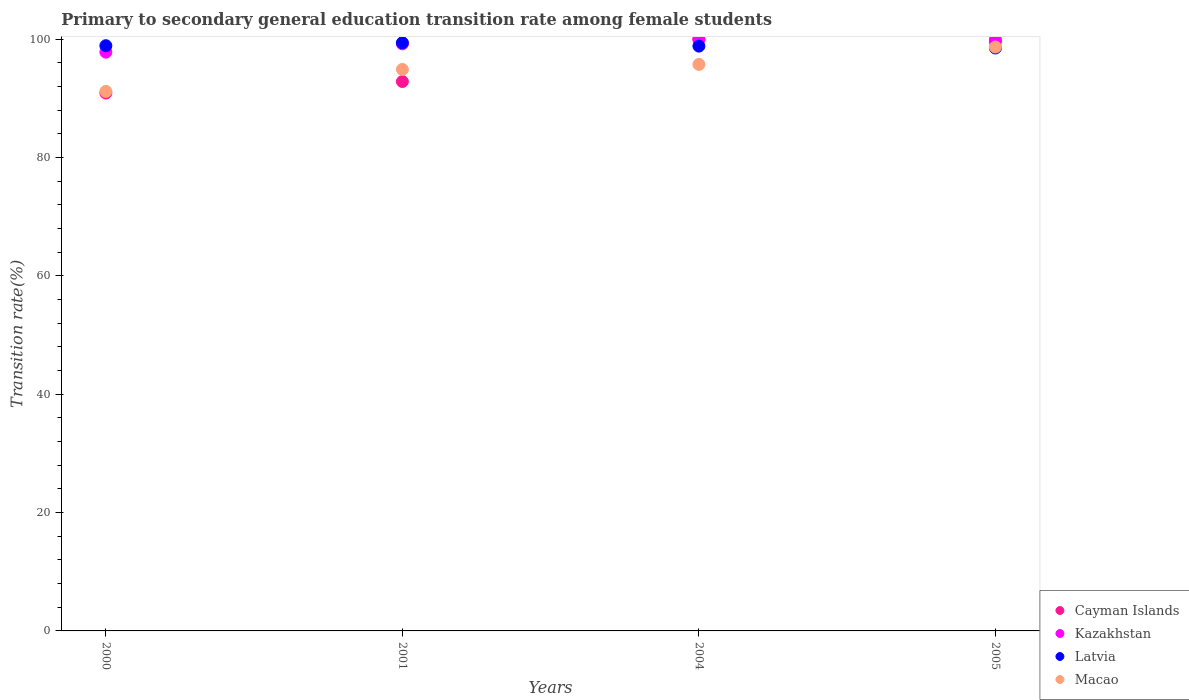How many different coloured dotlines are there?
Provide a short and direct response. 4. What is the transition rate in Cayman Islands in 2005?
Ensure brevity in your answer.  99.58. Across all years, what is the minimum transition rate in Latvia?
Offer a terse response. 98.52. In which year was the transition rate in Macao maximum?
Offer a terse response. 2005. What is the total transition rate in Macao in the graph?
Your response must be concise. 380.51. What is the difference between the transition rate in Kazakhstan in 2001 and that in 2004?
Give a very brief answer. -0.77. What is the difference between the transition rate in Macao in 2005 and the transition rate in Kazakhstan in 2000?
Ensure brevity in your answer.  0.86. What is the average transition rate in Latvia per year?
Offer a very short reply. 98.92. In the year 2000, what is the difference between the transition rate in Latvia and transition rate in Cayman Islands?
Provide a succinct answer. 8. In how many years, is the transition rate in Macao greater than 84 %?
Offer a terse response. 4. What is the ratio of the transition rate in Latvia in 2001 to that in 2004?
Provide a short and direct response. 1.01. Is the transition rate in Macao in 2000 less than that in 2001?
Provide a short and direct response. Yes. What is the difference between the highest and the second highest transition rate in Kazakhstan?
Give a very brief answer. 0.05. What is the difference between the highest and the lowest transition rate in Latvia?
Offer a terse response. 0.89. Is the sum of the transition rate in Cayman Islands in 2001 and 2004 greater than the maximum transition rate in Macao across all years?
Provide a succinct answer. Yes. Is it the case that in every year, the sum of the transition rate in Latvia and transition rate in Kazakhstan  is greater than the sum of transition rate in Macao and transition rate in Cayman Islands?
Offer a very short reply. Yes. Is it the case that in every year, the sum of the transition rate in Macao and transition rate in Latvia  is greater than the transition rate in Cayman Islands?
Give a very brief answer. Yes. Is the transition rate in Latvia strictly less than the transition rate in Cayman Islands over the years?
Keep it short and to the point. No. How many dotlines are there?
Keep it short and to the point. 4. How many years are there in the graph?
Offer a terse response. 4. Does the graph contain any zero values?
Offer a very short reply. No. Does the graph contain grids?
Provide a short and direct response. No. Where does the legend appear in the graph?
Make the answer very short. Bottom right. What is the title of the graph?
Make the answer very short. Primary to secondary general education transition rate among female students. What is the label or title of the X-axis?
Provide a succinct answer. Years. What is the label or title of the Y-axis?
Ensure brevity in your answer.  Transition rate(%). What is the Transition rate(%) in Cayman Islands in 2000?
Your answer should be compact. 90.91. What is the Transition rate(%) of Kazakhstan in 2000?
Provide a short and direct response. 97.82. What is the Transition rate(%) in Latvia in 2000?
Ensure brevity in your answer.  98.91. What is the Transition rate(%) of Macao in 2000?
Ensure brevity in your answer.  91.18. What is the Transition rate(%) in Cayman Islands in 2001?
Ensure brevity in your answer.  92.86. What is the Transition rate(%) in Kazakhstan in 2001?
Make the answer very short. 99.23. What is the Transition rate(%) of Latvia in 2001?
Offer a very short reply. 99.41. What is the Transition rate(%) of Macao in 2001?
Make the answer very short. 94.9. What is the Transition rate(%) in Cayman Islands in 2004?
Your response must be concise. 100. What is the Transition rate(%) of Latvia in 2004?
Make the answer very short. 98.84. What is the Transition rate(%) in Macao in 2004?
Your answer should be compact. 95.75. What is the Transition rate(%) in Cayman Islands in 2005?
Ensure brevity in your answer.  99.58. What is the Transition rate(%) of Kazakhstan in 2005?
Your answer should be compact. 99.95. What is the Transition rate(%) of Latvia in 2005?
Give a very brief answer. 98.52. What is the Transition rate(%) of Macao in 2005?
Make the answer very short. 98.68. Across all years, what is the maximum Transition rate(%) in Cayman Islands?
Provide a short and direct response. 100. Across all years, what is the maximum Transition rate(%) of Latvia?
Offer a terse response. 99.41. Across all years, what is the maximum Transition rate(%) in Macao?
Your answer should be very brief. 98.68. Across all years, what is the minimum Transition rate(%) in Cayman Islands?
Keep it short and to the point. 90.91. Across all years, what is the minimum Transition rate(%) in Kazakhstan?
Offer a very short reply. 97.82. Across all years, what is the minimum Transition rate(%) in Latvia?
Provide a succinct answer. 98.52. Across all years, what is the minimum Transition rate(%) of Macao?
Provide a succinct answer. 91.18. What is the total Transition rate(%) in Cayman Islands in the graph?
Your answer should be very brief. 383.34. What is the total Transition rate(%) of Kazakhstan in the graph?
Give a very brief answer. 397. What is the total Transition rate(%) in Latvia in the graph?
Your answer should be compact. 395.69. What is the total Transition rate(%) in Macao in the graph?
Ensure brevity in your answer.  380.51. What is the difference between the Transition rate(%) of Cayman Islands in 2000 and that in 2001?
Your response must be concise. -1.95. What is the difference between the Transition rate(%) in Kazakhstan in 2000 and that in 2001?
Provide a succinct answer. -1.41. What is the difference between the Transition rate(%) of Latvia in 2000 and that in 2001?
Provide a succinct answer. -0.5. What is the difference between the Transition rate(%) of Macao in 2000 and that in 2001?
Provide a short and direct response. -3.71. What is the difference between the Transition rate(%) in Cayman Islands in 2000 and that in 2004?
Keep it short and to the point. -9.09. What is the difference between the Transition rate(%) of Kazakhstan in 2000 and that in 2004?
Offer a very short reply. -2.18. What is the difference between the Transition rate(%) in Latvia in 2000 and that in 2004?
Your response must be concise. 0.07. What is the difference between the Transition rate(%) of Macao in 2000 and that in 2004?
Your answer should be very brief. -4.57. What is the difference between the Transition rate(%) in Cayman Islands in 2000 and that in 2005?
Make the answer very short. -8.67. What is the difference between the Transition rate(%) of Kazakhstan in 2000 and that in 2005?
Keep it short and to the point. -2.13. What is the difference between the Transition rate(%) of Latvia in 2000 and that in 2005?
Your answer should be very brief. 0.39. What is the difference between the Transition rate(%) in Macao in 2000 and that in 2005?
Give a very brief answer. -7.5. What is the difference between the Transition rate(%) of Cayman Islands in 2001 and that in 2004?
Offer a terse response. -7.14. What is the difference between the Transition rate(%) of Kazakhstan in 2001 and that in 2004?
Make the answer very short. -0.77. What is the difference between the Transition rate(%) in Latvia in 2001 and that in 2004?
Your answer should be very brief. 0.57. What is the difference between the Transition rate(%) in Macao in 2001 and that in 2004?
Offer a terse response. -0.85. What is the difference between the Transition rate(%) in Cayman Islands in 2001 and that in 2005?
Provide a short and direct response. -6.72. What is the difference between the Transition rate(%) of Kazakhstan in 2001 and that in 2005?
Keep it short and to the point. -0.72. What is the difference between the Transition rate(%) of Latvia in 2001 and that in 2005?
Offer a terse response. 0.89. What is the difference between the Transition rate(%) of Macao in 2001 and that in 2005?
Make the answer very short. -3.79. What is the difference between the Transition rate(%) of Cayman Islands in 2004 and that in 2005?
Offer a very short reply. 0.42. What is the difference between the Transition rate(%) of Kazakhstan in 2004 and that in 2005?
Provide a succinct answer. 0.05. What is the difference between the Transition rate(%) of Latvia in 2004 and that in 2005?
Make the answer very short. 0.32. What is the difference between the Transition rate(%) in Macao in 2004 and that in 2005?
Your answer should be compact. -2.93. What is the difference between the Transition rate(%) of Cayman Islands in 2000 and the Transition rate(%) of Kazakhstan in 2001?
Make the answer very short. -8.32. What is the difference between the Transition rate(%) of Cayman Islands in 2000 and the Transition rate(%) of Latvia in 2001?
Offer a very short reply. -8.5. What is the difference between the Transition rate(%) of Cayman Islands in 2000 and the Transition rate(%) of Macao in 2001?
Offer a very short reply. -3.99. What is the difference between the Transition rate(%) in Kazakhstan in 2000 and the Transition rate(%) in Latvia in 2001?
Give a very brief answer. -1.59. What is the difference between the Transition rate(%) of Kazakhstan in 2000 and the Transition rate(%) of Macao in 2001?
Your answer should be compact. 2.92. What is the difference between the Transition rate(%) in Latvia in 2000 and the Transition rate(%) in Macao in 2001?
Your answer should be very brief. 4.01. What is the difference between the Transition rate(%) in Cayman Islands in 2000 and the Transition rate(%) in Kazakhstan in 2004?
Your answer should be compact. -9.09. What is the difference between the Transition rate(%) in Cayman Islands in 2000 and the Transition rate(%) in Latvia in 2004?
Make the answer very short. -7.93. What is the difference between the Transition rate(%) of Cayman Islands in 2000 and the Transition rate(%) of Macao in 2004?
Keep it short and to the point. -4.84. What is the difference between the Transition rate(%) in Kazakhstan in 2000 and the Transition rate(%) in Latvia in 2004?
Your answer should be compact. -1.02. What is the difference between the Transition rate(%) of Kazakhstan in 2000 and the Transition rate(%) of Macao in 2004?
Your answer should be very brief. 2.07. What is the difference between the Transition rate(%) in Latvia in 2000 and the Transition rate(%) in Macao in 2004?
Give a very brief answer. 3.16. What is the difference between the Transition rate(%) in Cayman Islands in 2000 and the Transition rate(%) in Kazakhstan in 2005?
Offer a very short reply. -9.04. What is the difference between the Transition rate(%) in Cayman Islands in 2000 and the Transition rate(%) in Latvia in 2005?
Provide a short and direct response. -7.61. What is the difference between the Transition rate(%) of Cayman Islands in 2000 and the Transition rate(%) of Macao in 2005?
Provide a succinct answer. -7.78. What is the difference between the Transition rate(%) of Kazakhstan in 2000 and the Transition rate(%) of Latvia in 2005?
Provide a short and direct response. -0.7. What is the difference between the Transition rate(%) in Kazakhstan in 2000 and the Transition rate(%) in Macao in 2005?
Ensure brevity in your answer.  -0.86. What is the difference between the Transition rate(%) in Latvia in 2000 and the Transition rate(%) in Macao in 2005?
Give a very brief answer. 0.23. What is the difference between the Transition rate(%) of Cayman Islands in 2001 and the Transition rate(%) of Kazakhstan in 2004?
Give a very brief answer. -7.14. What is the difference between the Transition rate(%) of Cayman Islands in 2001 and the Transition rate(%) of Latvia in 2004?
Your answer should be compact. -5.98. What is the difference between the Transition rate(%) in Cayman Islands in 2001 and the Transition rate(%) in Macao in 2004?
Ensure brevity in your answer.  -2.89. What is the difference between the Transition rate(%) in Kazakhstan in 2001 and the Transition rate(%) in Latvia in 2004?
Ensure brevity in your answer.  0.39. What is the difference between the Transition rate(%) of Kazakhstan in 2001 and the Transition rate(%) of Macao in 2004?
Make the answer very short. 3.48. What is the difference between the Transition rate(%) of Latvia in 2001 and the Transition rate(%) of Macao in 2004?
Offer a very short reply. 3.66. What is the difference between the Transition rate(%) of Cayman Islands in 2001 and the Transition rate(%) of Kazakhstan in 2005?
Ensure brevity in your answer.  -7.1. What is the difference between the Transition rate(%) in Cayman Islands in 2001 and the Transition rate(%) in Latvia in 2005?
Your response must be concise. -5.67. What is the difference between the Transition rate(%) of Cayman Islands in 2001 and the Transition rate(%) of Macao in 2005?
Provide a short and direct response. -5.83. What is the difference between the Transition rate(%) in Kazakhstan in 2001 and the Transition rate(%) in Latvia in 2005?
Provide a succinct answer. 0.71. What is the difference between the Transition rate(%) in Kazakhstan in 2001 and the Transition rate(%) in Macao in 2005?
Your answer should be very brief. 0.54. What is the difference between the Transition rate(%) of Latvia in 2001 and the Transition rate(%) of Macao in 2005?
Provide a succinct answer. 0.72. What is the difference between the Transition rate(%) in Cayman Islands in 2004 and the Transition rate(%) in Kazakhstan in 2005?
Ensure brevity in your answer.  0.05. What is the difference between the Transition rate(%) of Cayman Islands in 2004 and the Transition rate(%) of Latvia in 2005?
Give a very brief answer. 1.48. What is the difference between the Transition rate(%) in Cayman Islands in 2004 and the Transition rate(%) in Macao in 2005?
Your response must be concise. 1.32. What is the difference between the Transition rate(%) in Kazakhstan in 2004 and the Transition rate(%) in Latvia in 2005?
Offer a terse response. 1.48. What is the difference between the Transition rate(%) in Kazakhstan in 2004 and the Transition rate(%) in Macao in 2005?
Keep it short and to the point. 1.32. What is the difference between the Transition rate(%) in Latvia in 2004 and the Transition rate(%) in Macao in 2005?
Make the answer very short. 0.16. What is the average Transition rate(%) in Cayman Islands per year?
Give a very brief answer. 95.84. What is the average Transition rate(%) in Kazakhstan per year?
Offer a terse response. 99.25. What is the average Transition rate(%) of Latvia per year?
Keep it short and to the point. 98.92. What is the average Transition rate(%) in Macao per year?
Ensure brevity in your answer.  95.13. In the year 2000, what is the difference between the Transition rate(%) in Cayman Islands and Transition rate(%) in Kazakhstan?
Make the answer very short. -6.91. In the year 2000, what is the difference between the Transition rate(%) of Cayman Islands and Transition rate(%) of Latvia?
Ensure brevity in your answer.  -8. In the year 2000, what is the difference between the Transition rate(%) of Cayman Islands and Transition rate(%) of Macao?
Give a very brief answer. -0.27. In the year 2000, what is the difference between the Transition rate(%) in Kazakhstan and Transition rate(%) in Latvia?
Give a very brief answer. -1.09. In the year 2000, what is the difference between the Transition rate(%) of Kazakhstan and Transition rate(%) of Macao?
Provide a short and direct response. 6.64. In the year 2000, what is the difference between the Transition rate(%) of Latvia and Transition rate(%) of Macao?
Your answer should be compact. 7.73. In the year 2001, what is the difference between the Transition rate(%) of Cayman Islands and Transition rate(%) of Kazakhstan?
Offer a very short reply. -6.37. In the year 2001, what is the difference between the Transition rate(%) of Cayman Islands and Transition rate(%) of Latvia?
Provide a succinct answer. -6.55. In the year 2001, what is the difference between the Transition rate(%) of Cayman Islands and Transition rate(%) of Macao?
Ensure brevity in your answer.  -2.04. In the year 2001, what is the difference between the Transition rate(%) in Kazakhstan and Transition rate(%) in Latvia?
Give a very brief answer. -0.18. In the year 2001, what is the difference between the Transition rate(%) in Kazakhstan and Transition rate(%) in Macao?
Make the answer very short. 4.33. In the year 2001, what is the difference between the Transition rate(%) of Latvia and Transition rate(%) of Macao?
Make the answer very short. 4.51. In the year 2004, what is the difference between the Transition rate(%) of Cayman Islands and Transition rate(%) of Latvia?
Your answer should be compact. 1.16. In the year 2004, what is the difference between the Transition rate(%) in Cayman Islands and Transition rate(%) in Macao?
Give a very brief answer. 4.25. In the year 2004, what is the difference between the Transition rate(%) in Kazakhstan and Transition rate(%) in Latvia?
Keep it short and to the point. 1.16. In the year 2004, what is the difference between the Transition rate(%) in Kazakhstan and Transition rate(%) in Macao?
Your answer should be very brief. 4.25. In the year 2004, what is the difference between the Transition rate(%) in Latvia and Transition rate(%) in Macao?
Keep it short and to the point. 3.09. In the year 2005, what is the difference between the Transition rate(%) in Cayman Islands and Transition rate(%) in Kazakhstan?
Make the answer very short. -0.38. In the year 2005, what is the difference between the Transition rate(%) of Cayman Islands and Transition rate(%) of Latvia?
Give a very brief answer. 1.05. In the year 2005, what is the difference between the Transition rate(%) of Cayman Islands and Transition rate(%) of Macao?
Make the answer very short. 0.89. In the year 2005, what is the difference between the Transition rate(%) of Kazakhstan and Transition rate(%) of Latvia?
Your answer should be compact. 1.43. In the year 2005, what is the difference between the Transition rate(%) of Kazakhstan and Transition rate(%) of Macao?
Provide a short and direct response. 1.27. In the year 2005, what is the difference between the Transition rate(%) of Latvia and Transition rate(%) of Macao?
Provide a succinct answer. -0.16. What is the ratio of the Transition rate(%) in Kazakhstan in 2000 to that in 2001?
Ensure brevity in your answer.  0.99. What is the ratio of the Transition rate(%) of Latvia in 2000 to that in 2001?
Your response must be concise. 0.99. What is the ratio of the Transition rate(%) in Macao in 2000 to that in 2001?
Your answer should be compact. 0.96. What is the ratio of the Transition rate(%) of Cayman Islands in 2000 to that in 2004?
Keep it short and to the point. 0.91. What is the ratio of the Transition rate(%) in Kazakhstan in 2000 to that in 2004?
Ensure brevity in your answer.  0.98. What is the ratio of the Transition rate(%) of Latvia in 2000 to that in 2004?
Give a very brief answer. 1. What is the ratio of the Transition rate(%) in Macao in 2000 to that in 2004?
Ensure brevity in your answer.  0.95. What is the ratio of the Transition rate(%) in Cayman Islands in 2000 to that in 2005?
Provide a succinct answer. 0.91. What is the ratio of the Transition rate(%) in Kazakhstan in 2000 to that in 2005?
Ensure brevity in your answer.  0.98. What is the ratio of the Transition rate(%) in Latvia in 2000 to that in 2005?
Your response must be concise. 1. What is the ratio of the Transition rate(%) of Macao in 2000 to that in 2005?
Ensure brevity in your answer.  0.92. What is the ratio of the Transition rate(%) in Cayman Islands in 2001 to that in 2004?
Provide a succinct answer. 0.93. What is the ratio of the Transition rate(%) in Latvia in 2001 to that in 2004?
Provide a short and direct response. 1.01. What is the ratio of the Transition rate(%) of Macao in 2001 to that in 2004?
Your response must be concise. 0.99. What is the ratio of the Transition rate(%) in Cayman Islands in 2001 to that in 2005?
Your answer should be compact. 0.93. What is the ratio of the Transition rate(%) in Latvia in 2001 to that in 2005?
Keep it short and to the point. 1.01. What is the ratio of the Transition rate(%) in Macao in 2001 to that in 2005?
Your response must be concise. 0.96. What is the ratio of the Transition rate(%) in Cayman Islands in 2004 to that in 2005?
Your response must be concise. 1. What is the ratio of the Transition rate(%) of Macao in 2004 to that in 2005?
Provide a short and direct response. 0.97. What is the difference between the highest and the second highest Transition rate(%) in Cayman Islands?
Offer a terse response. 0.42. What is the difference between the highest and the second highest Transition rate(%) in Kazakhstan?
Offer a terse response. 0.05. What is the difference between the highest and the second highest Transition rate(%) in Latvia?
Provide a short and direct response. 0.5. What is the difference between the highest and the second highest Transition rate(%) in Macao?
Keep it short and to the point. 2.93. What is the difference between the highest and the lowest Transition rate(%) in Cayman Islands?
Your response must be concise. 9.09. What is the difference between the highest and the lowest Transition rate(%) of Kazakhstan?
Give a very brief answer. 2.18. What is the difference between the highest and the lowest Transition rate(%) in Latvia?
Offer a very short reply. 0.89. What is the difference between the highest and the lowest Transition rate(%) in Macao?
Your answer should be very brief. 7.5. 